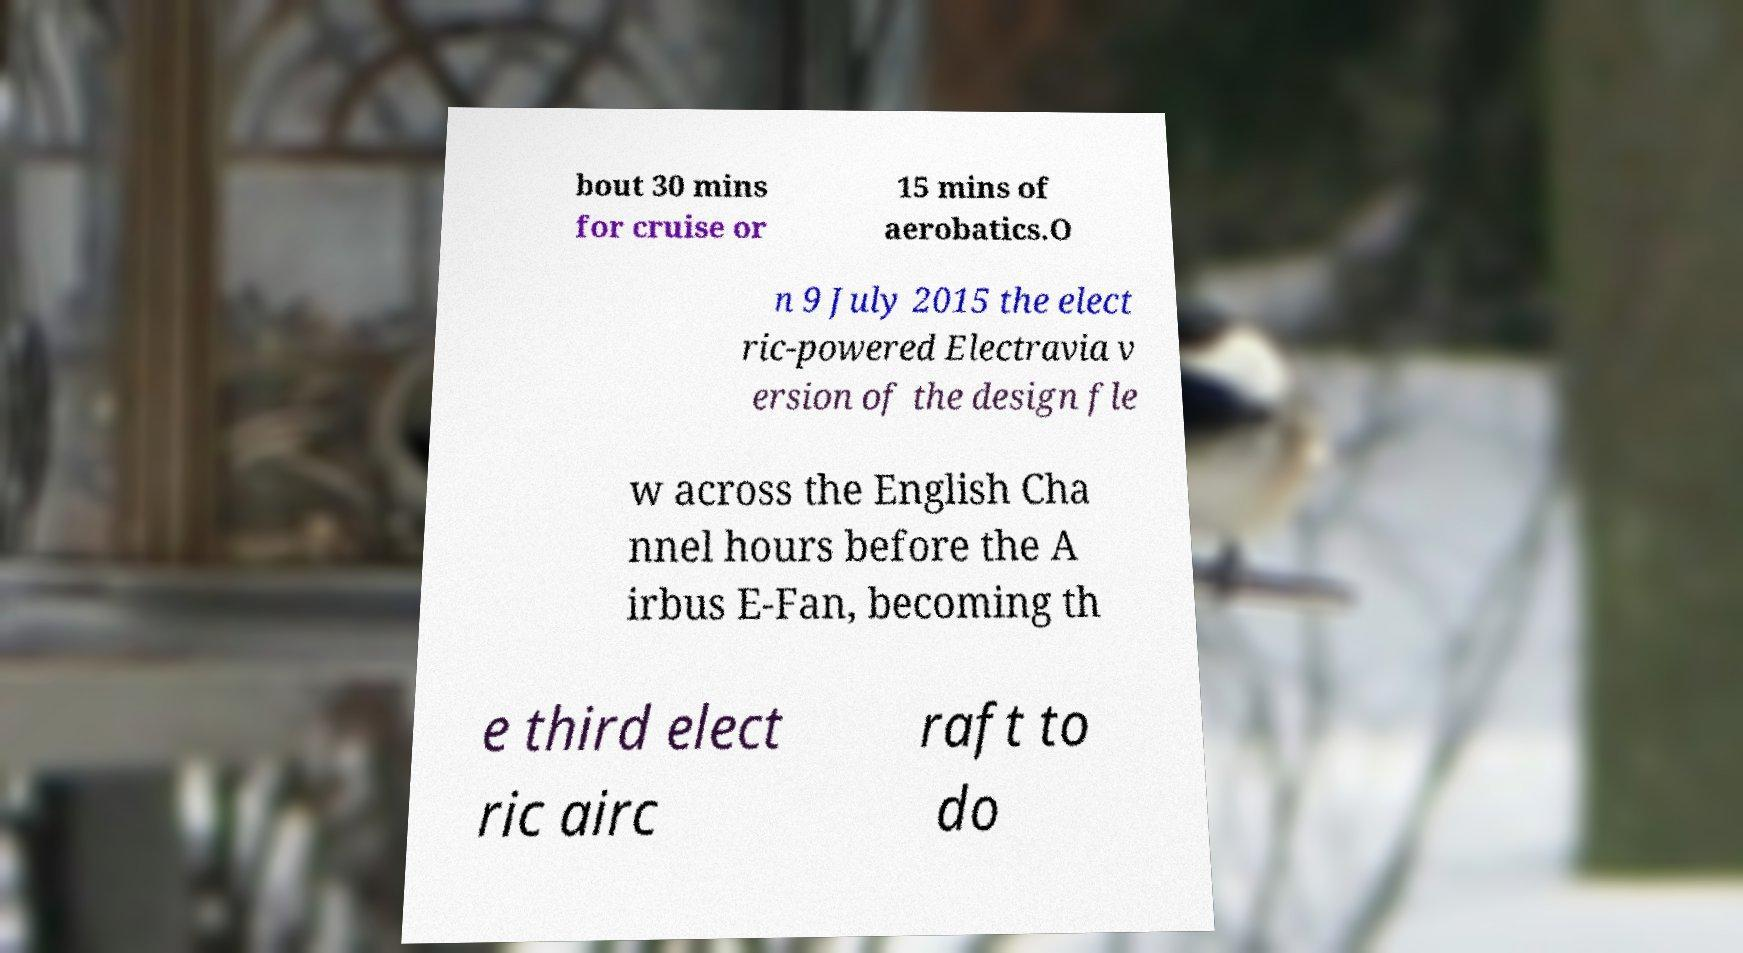Please identify and transcribe the text found in this image. bout 30 mins for cruise or 15 mins of aerobatics.O n 9 July 2015 the elect ric-powered Electravia v ersion of the design fle w across the English Cha nnel hours before the A irbus E-Fan, becoming th e third elect ric airc raft to do 